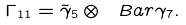Convert formula to latex. <formula><loc_0><loc_0><loc_500><loc_500>\Gamma _ { 1 1 } = \tilde { \gamma } _ { 5 } \otimes \ B a r \gamma _ { 7 } .</formula> 